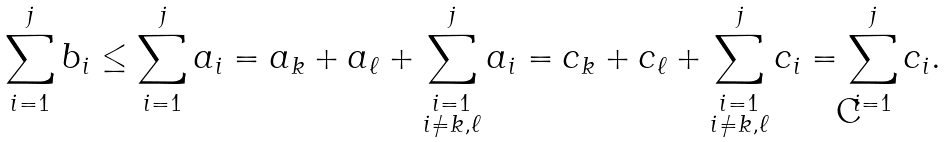Convert formula to latex. <formula><loc_0><loc_0><loc_500><loc_500>\sum _ { i = 1 } ^ { j } b _ { i } \leq \sum _ { i = 1 } ^ { j } a _ { i } = a _ { k } + a _ { \ell } + \sum _ { \substack { i = 1 \\ i \neq k , \ell } } ^ { j } a _ { i } = c _ { k } + c _ { \ell } + \sum _ { \substack { i = 1 \\ i \neq k , \ell } } ^ { j } c _ { i } = \sum _ { i = 1 } ^ { j } c _ { i } .</formula> 